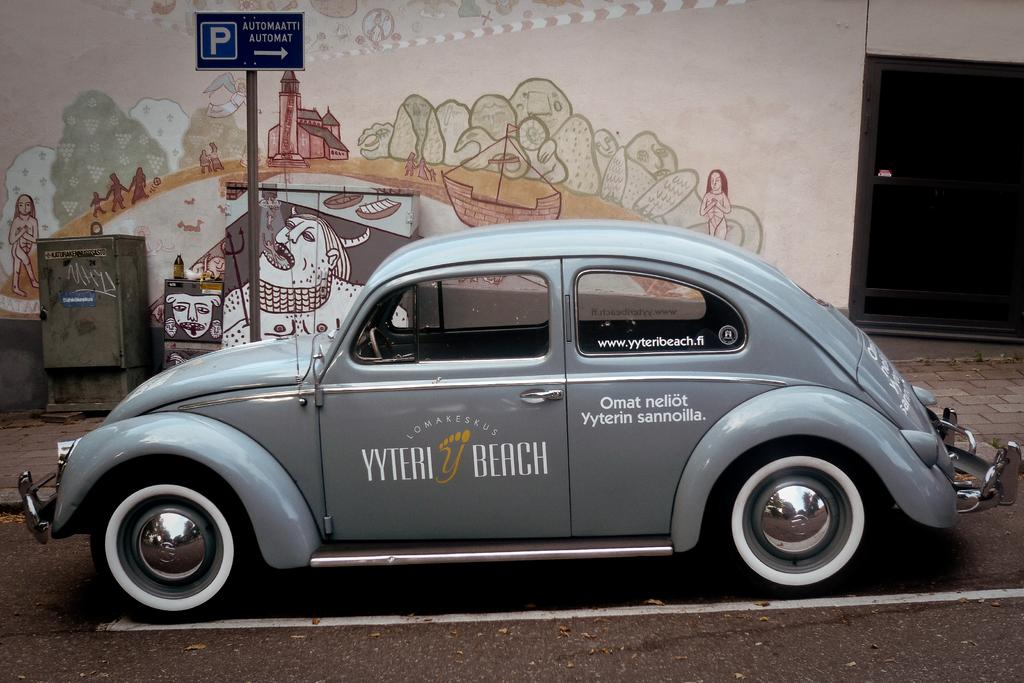What is the main object in the image? There is a car in the image. What can be seen on the sidewalk? There is a sign board on the sidewalk. What is on the wall in the image? There is a painting on a wall. What type of furniture is present in the image? There is a metal cupboard in the image. What is placed on another cupboard in the image? There is a water bottle on another cupboard. What type of plant is growing inside the car in the image? There is no plant growing inside the car in the image. What color is the cabbage on the roof of the car? There is no cabbage present in the image. 